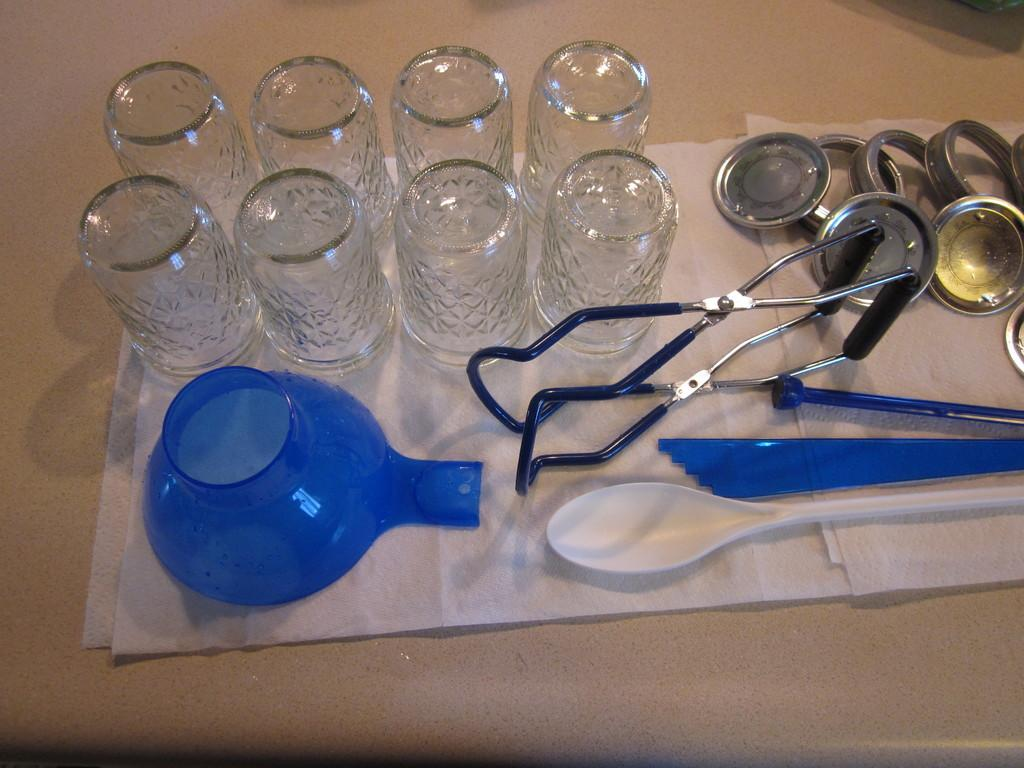What type of object is present in the image that people use to see? There is a pair of glasses in the image that people use to see. What can be found in the image that is commonly used for holding or serving food? There is a bowl in the image that is commonly used for holding or serving food. What utensil is visible in the image that is often used for eating or stirring? There is a spoon in the image that is often used for eating or stirring. What other objects in the image are related to holding or serving food or drink? There are vessels in the image that are related to holding or serving food or drink. How does the mother in the image support the vessels? There is no mother present in the image, and therefore no support for the vessels can be observed. 